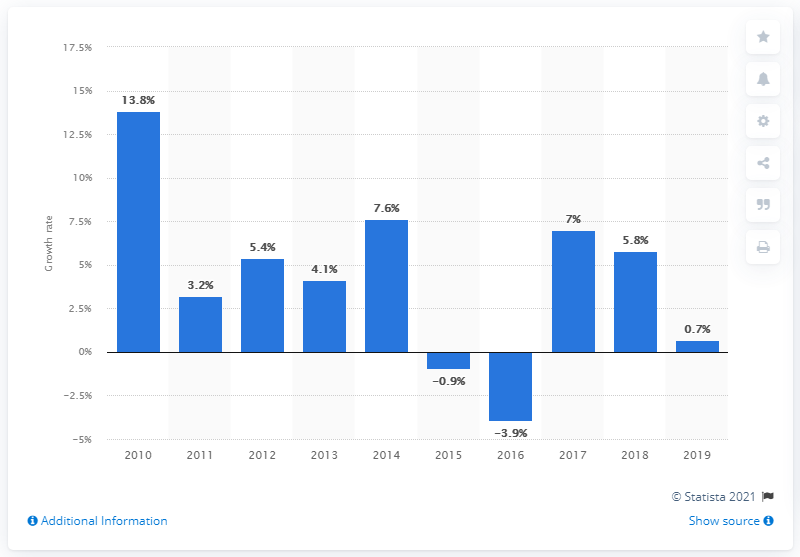Identify some key points in this picture. In 2019, the volume of freight in Canada increased by 0.7% in ton-kilometers compared to the previous year. 